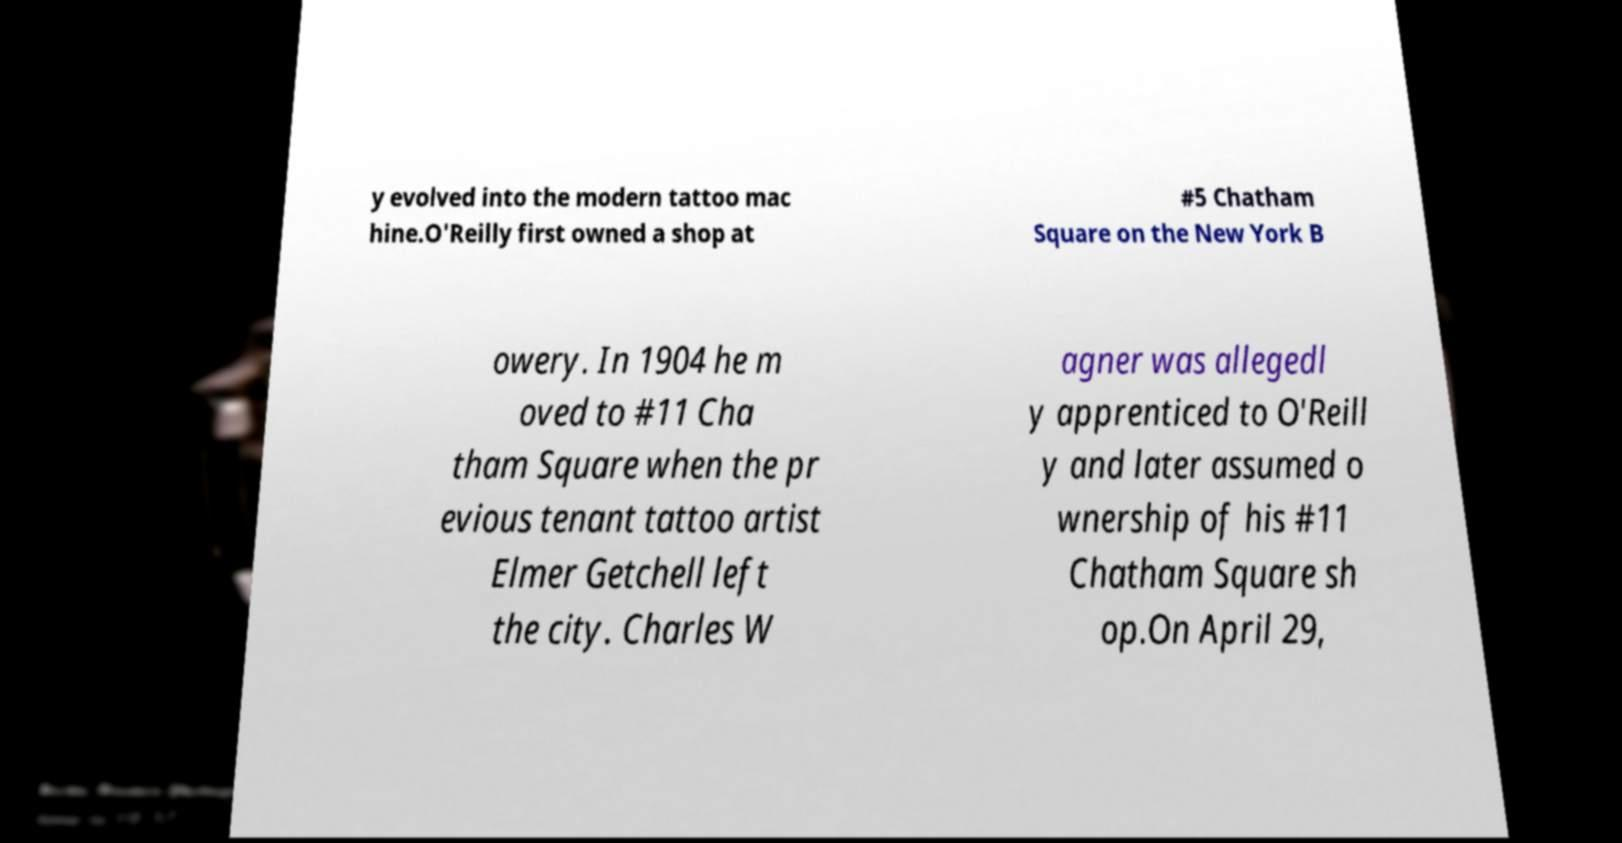For documentation purposes, I need the text within this image transcribed. Could you provide that? y evolved into the modern tattoo mac hine.O'Reilly first owned a shop at #5 Chatham Square on the New York B owery. In 1904 he m oved to #11 Cha tham Square when the pr evious tenant tattoo artist Elmer Getchell left the city. Charles W agner was allegedl y apprenticed to O'Reill y and later assumed o wnership of his #11 Chatham Square sh op.On April 29, 